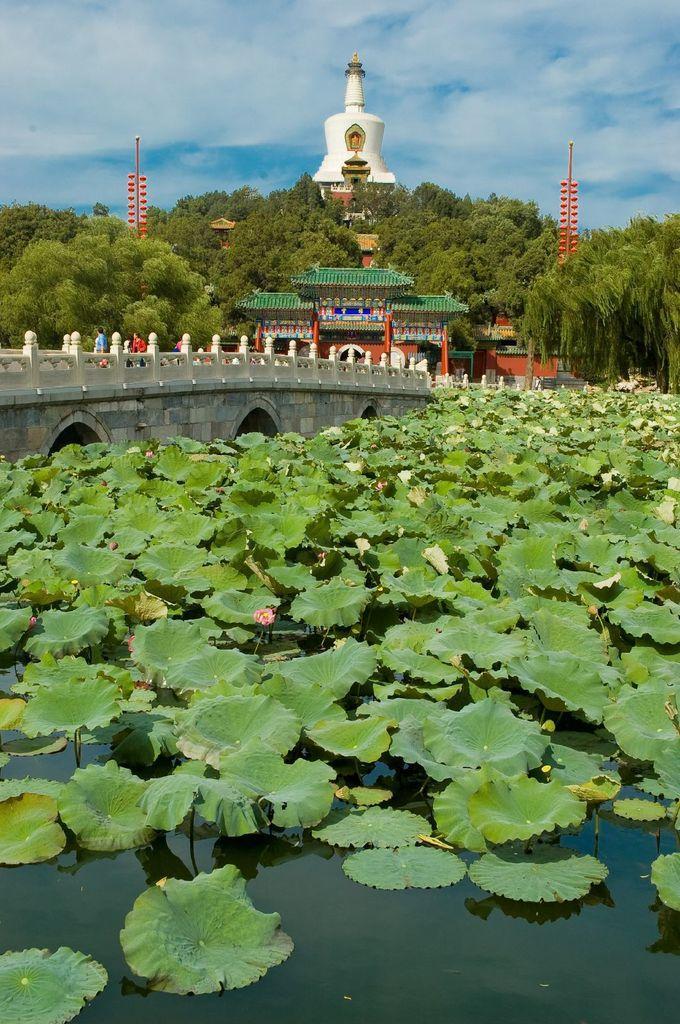Describe this image in one or two sentences. There are flower pods on the water. There is a bridge on which people are present. There are buildings and trees. 